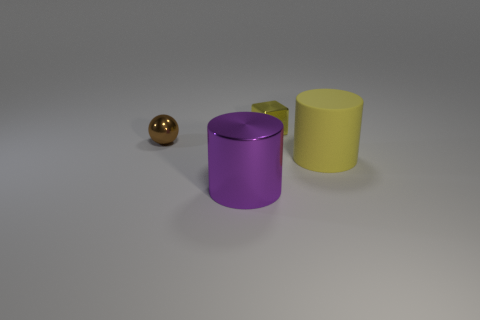There is a cylinder that is the same material as the small brown thing; what size is it?
Provide a succinct answer. Large. Is there any other thing that has the same material as the yellow cylinder?
Ensure brevity in your answer.  No. How many other things are the same shape as the large shiny thing?
Ensure brevity in your answer.  1. There is a yellow cube; what number of objects are to the left of it?
Your answer should be very brief. 2. There is a yellow object in front of the small brown metal thing; does it have the same size as the yellow thing that is behind the yellow cylinder?
Give a very brief answer. No. What number of other objects are there of the same size as the metal cylinder?
Give a very brief answer. 1. What material is the tiny object that is left of the large thing that is in front of the large cylinder behind the purple object made of?
Offer a terse response. Metal. Do the yellow metallic thing and the cylinder in front of the big yellow thing have the same size?
Your answer should be compact. No. How big is the thing that is both in front of the sphere and on the left side of the yellow cylinder?
Offer a very short reply. Large. Is there a tiny object that has the same color as the rubber cylinder?
Your response must be concise. Yes. 